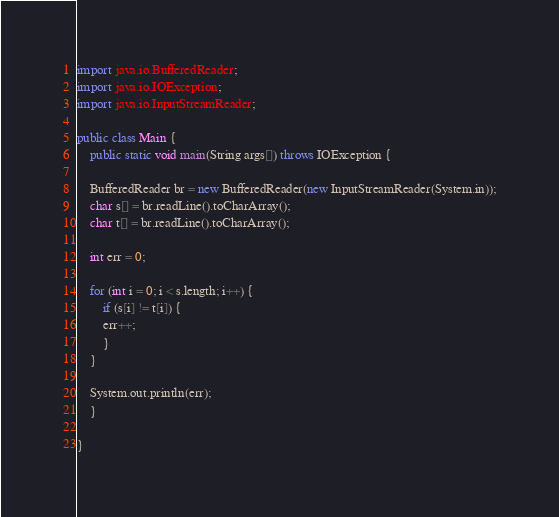<code> <loc_0><loc_0><loc_500><loc_500><_Java_>import java.io.BufferedReader;
import java.io.IOException;
import java.io.InputStreamReader;

public class Main {
    public static void main(String args[]) throws IOException {

	BufferedReader br = new BufferedReader(new InputStreamReader(System.in));
	char s[] = br.readLine().toCharArray();
	char t[] = br.readLine().toCharArray();

	int err = 0;

	for (int i = 0; i < s.length; i++) {
	    if (s[i] != t[i]) {
		err++;
	    }
	}

	System.out.println(err);
    }

}</code> 